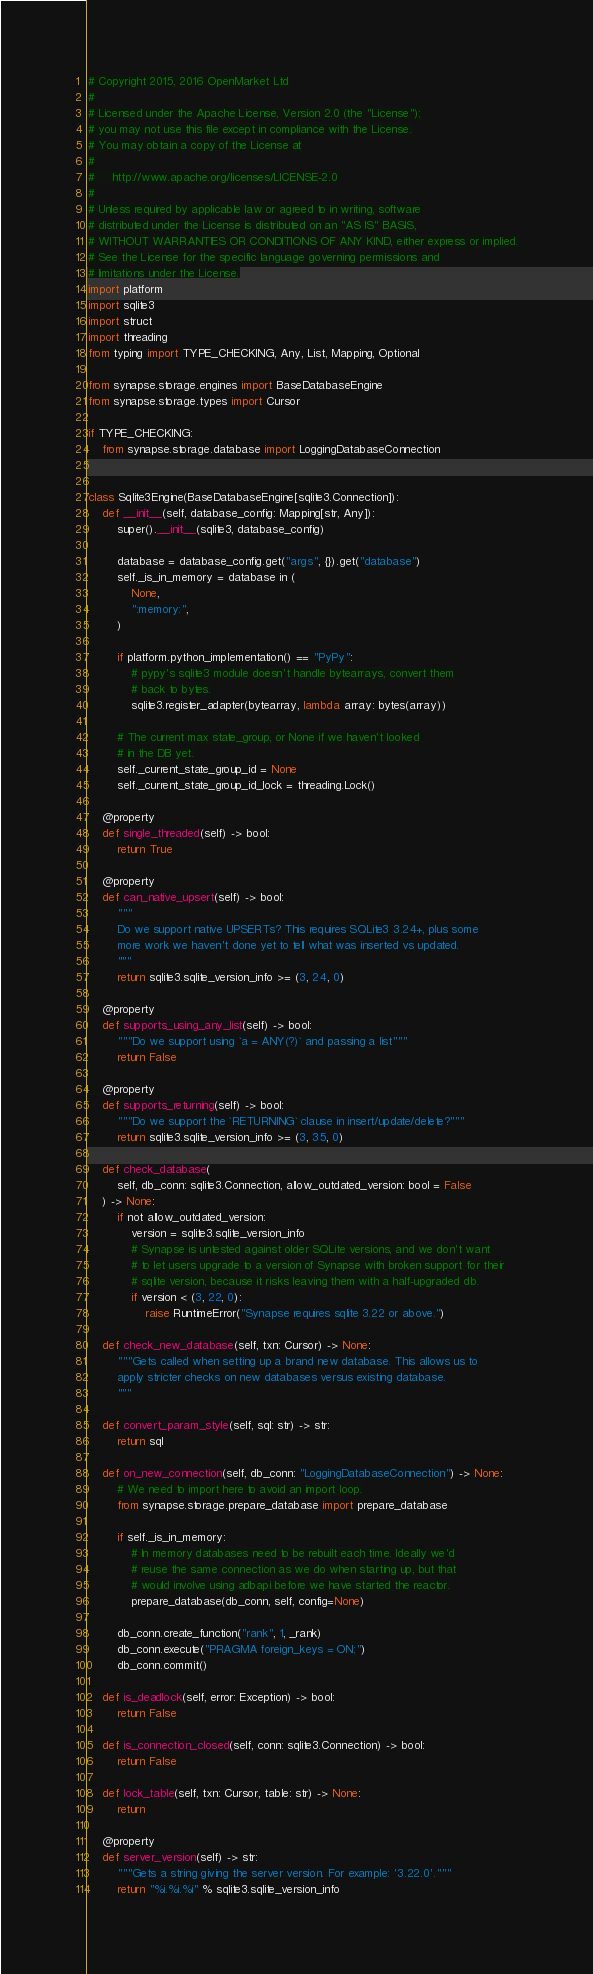Convert code to text. <code><loc_0><loc_0><loc_500><loc_500><_Python_># Copyright 2015, 2016 OpenMarket Ltd
#
# Licensed under the Apache License, Version 2.0 (the "License");
# you may not use this file except in compliance with the License.
# You may obtain a copy of the License at
#
#     http://www.apache.org/licenses/LICENSE-2.0
#
# Unless required by applicable law or agreed to in writing, software
# distributed under the License is distributed on an "AS IS" BASIS,
# WITHOUT WARRANTIES OR CONDITIONS OF ANY KIND, either express or implied.
# See the License for the specific language governing permissions and
# limitations under the License.
import platform
import sqlite3
import struct
import threading
from typing import TYPE_CHECKING, Any, List, Mapping, Optional

from synapse.storage.engines import BaseDatabaseEngine
from synapse.storage.types import Cursor

if TYPE_CHECKING:
    from synapse.storage.database import LoggingDatabaseConnection


class Sqlite3Engine(BaseDatabaseEngine[sqlite3.Connection]):
    def __init__(self, database_config: Mapping[str, Any]):
        super().__init__(sqlite3, database_config)

        database = database_config.get("args", {}).get("database")
        self._is_in_memory = database in (
            None,
            ":memory:",
        )

        if platform.python_implementation() == "PyPy":
            # pypy's sqlite3 module doesn't handle bytearrays, convert them
            # back to bytes.
            sqlite3.register_adapter(bytearray, lambda array: bytes(array))

        # The current max state_group, or None if we haven't looked
        # in the DB yet.
        self._current_state_group_id = None
        self._current_state_group_id_lock = threading.Lock()

    @property
    def single_threaded(self) -> bool:
        return True

    @property
    def can_native_upsert(self) -> bool:
        """
        Do we support native UPSERTs? This requires SQLite3 3.24+, plus some
        more work we haven't done yet to tell what was inserted vs updated.
        """
        return sqlite3.sqlite_version_info >= (3, 24, 0)

    @property
    def supports_using_any_list(self) -> bool:
        """Do we support using `a = ANY(?)` and passing a list"""
        return False

    @property
    def supports_returning(self) -> bool:
        """Do we support the `RETURNING` clause in insert/update/delete?"""
        return sqlite3.sqlite_version_info >= (3, 35, 0)

    def check_database(
        self, db_conn: sqlite3.Connection, allow_outdated_version: bool = False
    ) -> None:
        if not allow_outdated_version:
            version = sqlite3.sqlite_version_info
            # Synapse is untested against older SQLite versions, and we don't want
            # to let users upgrade to a version of Synapse with broken support for their
            # sqlite version, because it risks leaving them with a half-upgraded db.
            if version < (3, 22, 0):
                raise RuntimeError("Synapse requires sqlite 3.22 or above.")

    def check_new_database(self, txn: Cursor) -> None:
        """Gets called when setting up a brand new database. This allows us to
        apply stricter checks on new databases versus existing database.
        """

    def convert_param_style(self, sql: str) -> str:
        return sql

    def on_new_connection(self, db_conn: "LoggingDatabaseConnection") -> None:
        # We need to import here to avoid an import loop.
        from synapse.storage.prepare_database import prepare_database

        if self._is_in_memory:
            # In memory databases need to be rebuilt each time. Ideally we'd
            # reuse the same connection as we do when starting up, but that
            # would involve using adbapi before we have started the reactor.
            prepare_database(db_conn, self, config=None)

        db_conn.create_function("rank", 1, _rank)
        db_conn.execute("PRAGMA foreign_keys = ON;")
        db_conn.commit()

    def is_deadlock(self, error: Exception) -> bool:
        return False

    def is_connection_closed(self, conn: sqlite3.Connection) -> bool:
        return False

    def lock_table(self, txn: Cursor, table: str) -> None:
        return

    @property
    def server_version(self) -> str:
        """Gets a string giving the server version. For example: '3.22.0'."""
        return "%i.%i.%i" % sqlite3.sqlite_version_info
</code> 